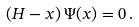<formula> <loc_0><loc_0><loc_500><loc_500>( H - x ) \, \Psi ( x ) = 0 \, .</formula> 